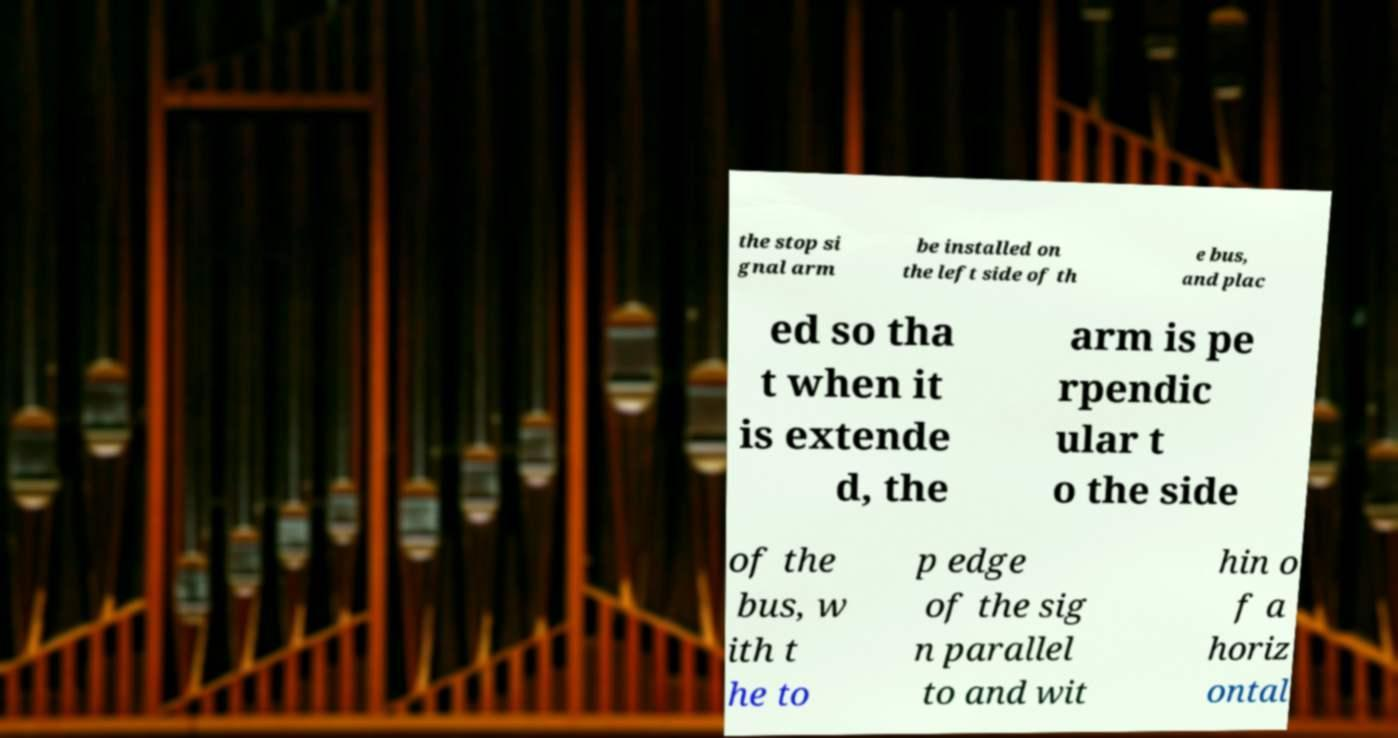There's text embedded in this image that I need extracted. Can you transcribe it verbatim? the stop si gnal arm be installed on the left side of th e bus, and plac ed so tha t when it is extende d, the arm is pe rpendic ular t o the side of the bus, w ith t he to p edge of the sig n parallel to and wit hin o f a horiz ontal 